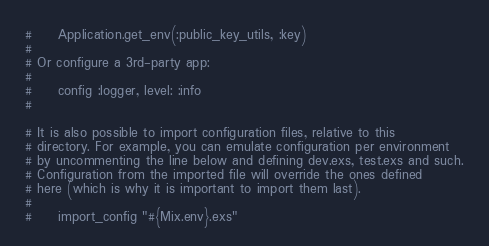<code> <loc_0><loc_0><loc_500><loc_500><_Elixir_>#     Application.get_env(:public_key_utils, :key)
#
# Or configure a 3rd-party app:
#
#     config :logger, level: :info
#

# It is also possible to import configuration files, relative to this
# directory. For example, you can emulate configuration per environment
# by uncommenting the line below and defining dev.exs, test.exs and such.
# Configuration from the imported file will override the ones defined
# here (which is why it is important to import them last).
#
#     import_config "#{Mix.env}.exs"
</code> 